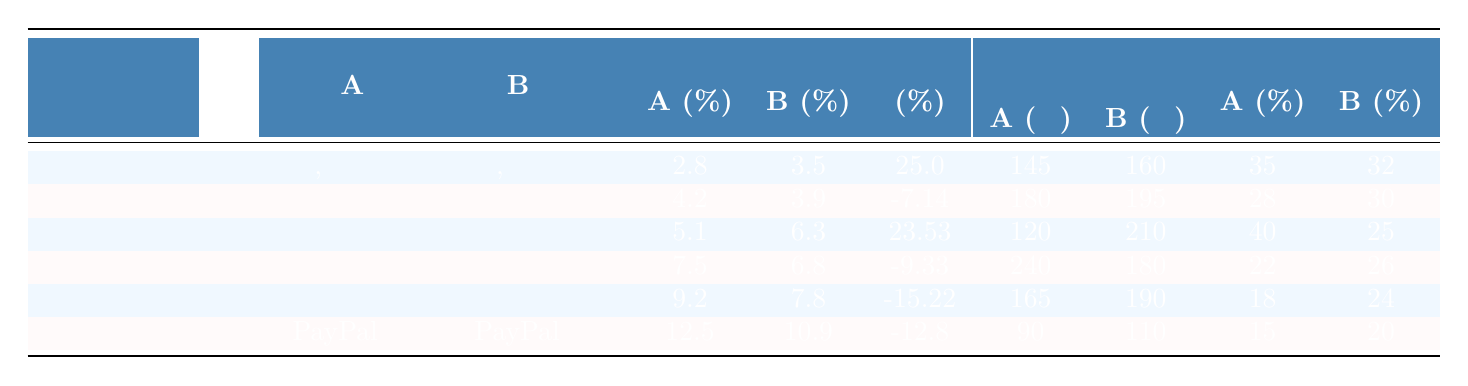What is the conversion rate of option A for the "Кнопка призыва к действию"? The table shows that the conversion rate for option A (Синяя, округлая) for the "Кнопка призыва к действию" is 2.8%.
Answer: 2.8% What is the improvement percentage for the "Форма регистрации"? According to the table, the improvement percentage for the "Форма регистрации" comparing option A (Одностраничная) to option B (Многоступенчатая) is 23.53%.
Answer: 23.53% Which interface element has the lowest conversion rate for variant A? By comparing the conversion rates in the table, "Кнопка призыва к действию" has the lowest conversion rate for variant A at 2.8%.
Answer: "Кнопка призыва к действию" What is the total average session time for variant B across all interface elements? First, calculate the total session time for variant B: 160 + 195 + 210 + 180 + 190 + 110 = 1,145 seconds. Then, divide by the number of elements (6): 1,145 / 6 = 190.83 seconds.
Answer: 190.83 seconds Did the "Карточка товара" show an improvement in conversion from variant A to variant B? The conversion rate for variant A (С видео) is 7.5% and for variant B (Только фото) it is 6.8%. Since 6.8% is less than 7.5%, there was no improvement.
Answer: No What is the difference in conversion rates between variant A and variant B for the "Поисковая строка"? The conversion rate for variant A (С автодополнением) is 9.2%, and for variant B (Без автодополнения) it is 7.8%. The difference is 9.2% - 7.8% = 1.4%.
Answer: 1.4% For which element did variant B have a lower bounce rate compared to variant A? By examining the bounce rates, the "Форма регистрации" has a bounce rate of 25% for variant B and 40% for variant A. Thus, variant B had a lower bounce rate.
Answer: "Форма регистрации" Which element shows the highest conversion rate and what is that rate? The "Страница оплаты" shows the highest conversion rate for variant A, which is 12.5%.
Answer: 12.5% Is the session time for variant B always higher than variant A? Not always; for "Кнопка призыва к действию" and "Форма регистрации", the session time for variant A is higher than variant B. Thus, it is false.
Answer: No 